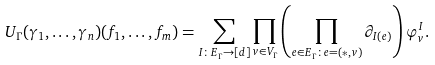<formula> <loc_0><loc_0><loc_500><loc_500>U _ { \Gamma } ( \gamma _ { 1 } , \dots , \gamma _ { n } ) ( f _ { 1 } , \dots , f _ { m } ) = \sum _ { I \colon E _ { \Gamma } \to [ d ] } \prod _ { v \in V _ { \Gamma } } \left ( \prod _ { e \in E _ { \Gamma } \colon e = ( * , v ) } \partial _ { I ( e ) } \right ) \varphi _ { v } ^ { I } .</formula> 